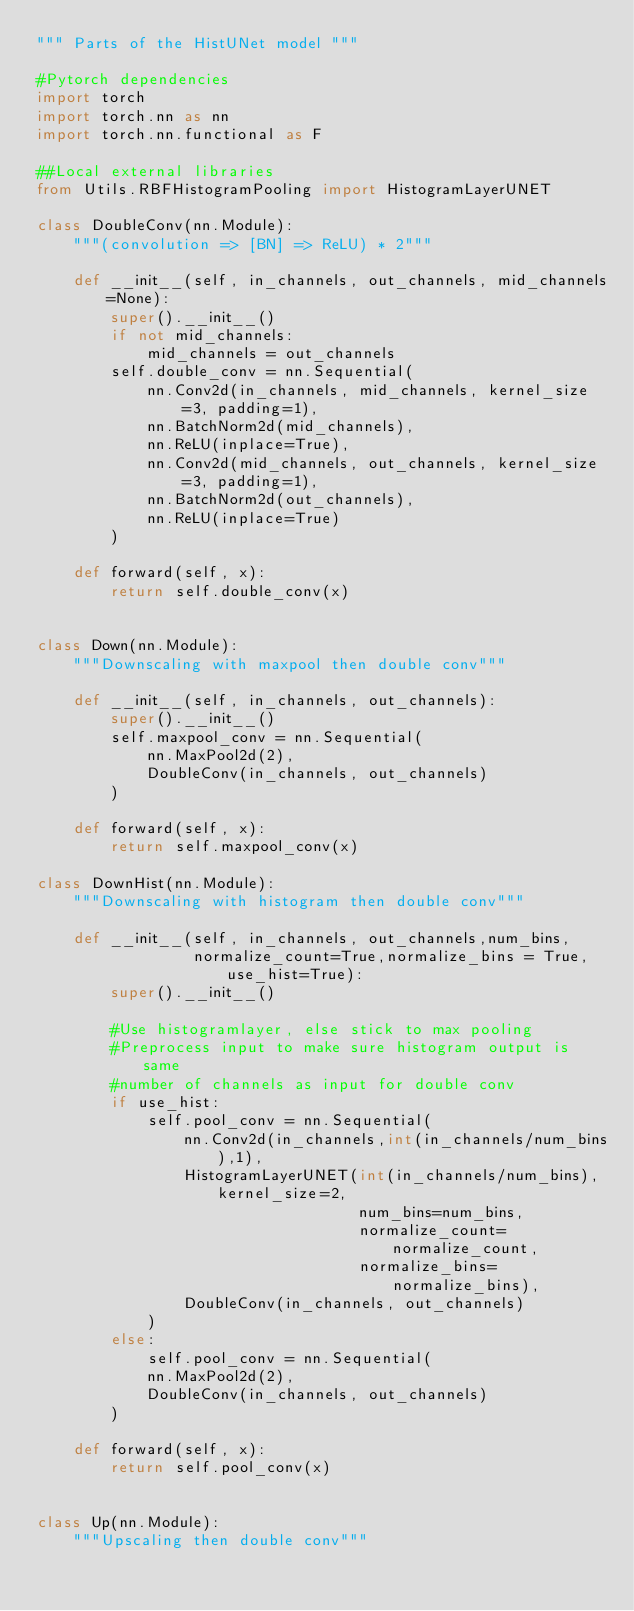Convert code to text. <code><loc_0><loc_0><loc_500><loc_500><_Python_>""" Parts of the HistUNet model """

#Pytorch dependencies
import torch
import torch.nn as nn
import torch.nn.functional as F

##Local external libraries
from Utils.RBFHistogramPooling import HistogramLayerUNET

class DoubleConv(nn.Module):
    """(convolution => [BN] => ReLU) * 2"""

    def __init__(self, in_channels, out_channels, mid_channels=None):
        super().__init__()
        if not mid_channels:
            mid_channels = out_channels
        self.double_conv = nn.Sequential(
            nn.Conv2d(in_channels, mid_channels, kernel_size=3, padding=1),
            nn.BatchNorm2d(mid_channels),
            nn.ReLU(inplace=True),
            nn.Conv2d(mid_channels, out_channels, kernel_size=3, padding=1),
            nn.BatchNorm2d(out_channels),
            nn.ReLU(inplace=True)
        )

    def forward(self, x):
        return self.double_conv(x)


class Down(nn.Module):
    """Downscaling with maxpool then double conv"""

    def __init__(self, in_channels, out_channels):
        super().__init__()
        self.maxpool_conv = nn.Sequential(
            nn.MaxPool2d(2),
            DoubleConv(in_channels, out_channels)
        )

    def forward(self, x):
        return self.maxpool_conv(x)
    
class DownHist(nn.Module):
    """Downscaling with histogram then double conv"""

    def __init__(self, in_channels, out_channels,num_bins,
                 normalize_count=True,normalize_bins = True,use_hist=True):
        super().__init__()
        
        #Use histogramlayer, else stick to max pooling
        #Preprocess input to make sure histogram output is same 
        #number of channels as input for double conv
        if use_hist:
            self.pool_conv = nn.Sequential(
                nn.Conv2d(in_channels,int(in_channels/num_bins),1),
                HistogramLayerUNET(int(in_channels/num_bins),kernel_size=2,
                                   num_bins=num_bins,
                                   normalize_count=normalize_count,
                                   normalize_bins=normalize_bins),
                DoubleConv(in_channels, out_channels)
            )
        else:
            self.pool_conv = nn.Sequential(
            nn.MaxPool2d(2),
            DoubleConv(in_channels, out_channels)
        )

    def forward(self, x):
        return self.pool_conv(x)


class Up(nn.Module):
    """Upscaling then double conv"""
</code> 